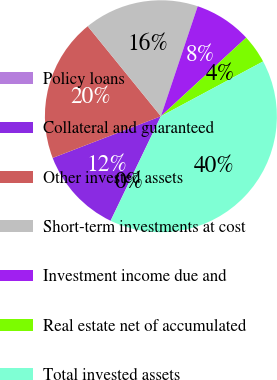Convert chart. <chart><loc_0><loc_0><loc_500><loc_500><pie_chart><fcel>Policy loans<fcel>Collateral and guaranteed<fcel>Other invested assets<fcel>Short-term investments at cost<fcel>Investment income due and<fcel>Real estate net of accumulated<fcel>Total invested assets<nl><fcel>0.02%<fcel>12.0%<fcel>19.99%<fcel>16.0%<fcel>8.01%<fcel>4.02%<fcel>39.96%<nl></chart> 